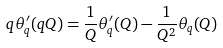<formula> <loc_0><loc_0><loc_500><loc_500>q \theta _ { q } ^ { \prime } ( q Q ) = \frac { 1 } { Q } \theta _ { q } ^ { \prime } ( Q ) - \frac { 1 } { Q ^ { 2 } } \theta _ { q } ( Q )</formula> 